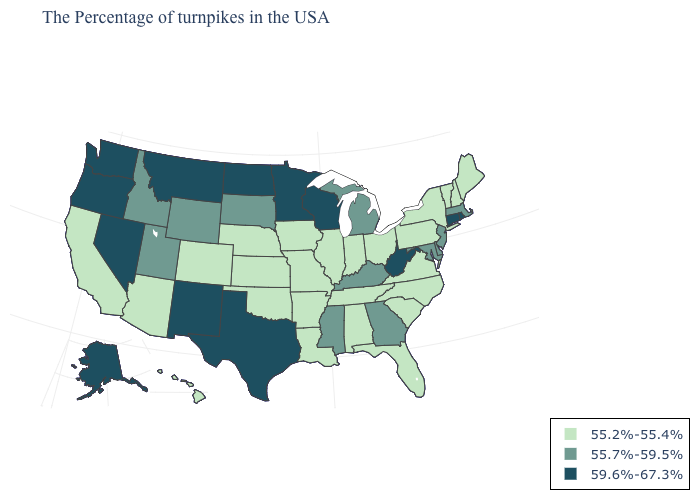What is the value of South Carolina?
Concise answer only. 55.2%-55.4%. How many symbols are there in the legend?
Keep it brief. 3. Which states hav the highest value in the Northeast?
Write a very short answer. Rhode Island, Connecticut. Name the states that have a value in the range 59.6%-67.3%?
Answer briefly. Rhode Island, Connecticut, West Virginia, Wisconsin, Minnesota, Texas, North Dakota, New Mexico, Montana, Nevada, Washington, Oregon, Alaska. What is the lowest value in states that border Kentucky?
Write a very short answer. 55.2%-55.4%. How many symbols are there in the legend?
Short answer required. 3. What is the value of Virginia?
Quick response, please. 55.2%-55.4%. Among the states that border New Hampshire , does Vermont have the highest value?
Quick response, please. No. What is the highest value in the South ?
Short answer required. 59.6%-67.3%. What is the value of South Carolina?
Answer briefly. 55.2%-55.4%. Does the first symbol in the legend represent the smallest category?
Quick response, please. Yes. Does the first symbol in the legend represent the smallest category?
Be succinct. Yes. Does Illinois have the lowest value in the MidWest?
Write a very short answer. Yes. What is the value of Tennessee?
Write a very short answer. 55.2%-55.4%. 